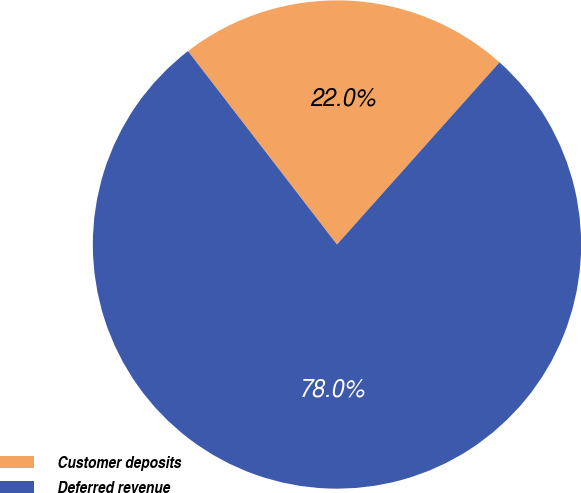Convert chart. <chart><loc_0><loc_0><loc_500><loc_500><pie_chart><fcel>Customer deposits<fcel>Deferred revenue<nl><fcel>22.04%<fcel>77.96%<nl></chart> 